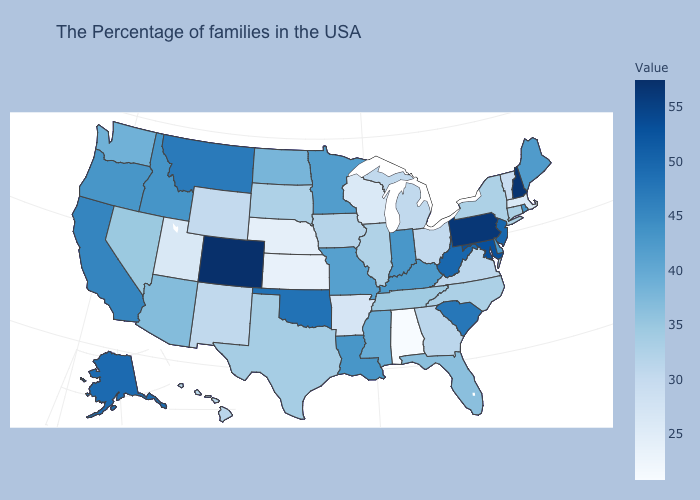Which states have the highest value in the USA?
Short answer required. Colorado. Which states have the lowest value in the South?
Concise answer only. Alabama. Which states hav the highest value in the West?
Write a very short answer. Colorado. Does Alabama have the lowest value in the USA?
Be succinct. Yes. Among the states that border Oregon , does Idaho have the lowest value?
Keep it brief. No. 